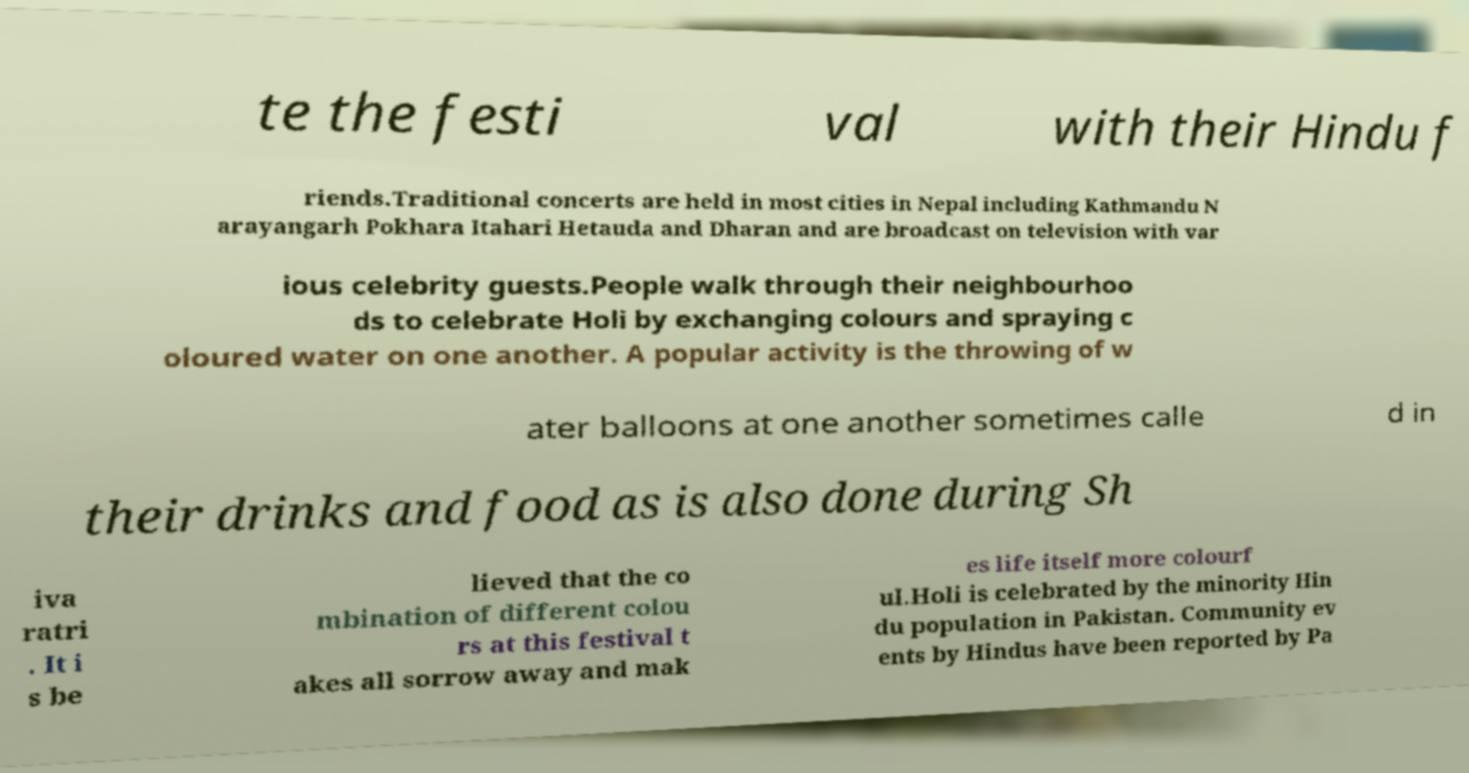Can you accurately transcribe the text from the provided image for me? te the festi val with their Hindu f riends.Traditional concerts are held in most cities in Nepal including Kathmandu N arayangarh Pokhara Itahari Hetauda and Dharan and are broadcast on television with var ious celebrity guests.People walk through their neighbourhoo ds to celebrate Holi by exchanging colours and spraying c oloured water on one another. A popular activity is the throwing of w ater balloons at one another sometimes calle d in their drinks and food as is also done during Sh iva ratri . It i s be lieved that the co mbination of different colou rs at this festival t akes all sorrow away and mak es life itself more colourf ul.Holi is celebrated by the minority Hin du population in Pakistan. Community ev ents by Hindus have been reported by Pa 